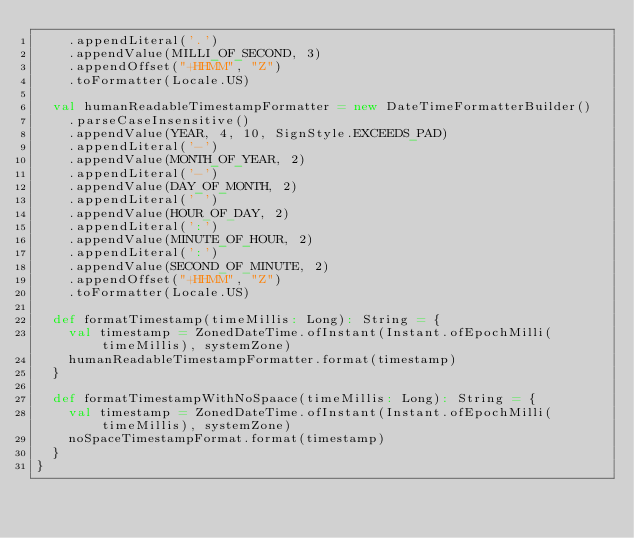Convert code to text. <code><loc_0><loc_0><loc_500><loc_500><_Scala_>    .appendLiteral('.')
    .appendValue(MILLI_OF_SECOND, 3)
    .appendOffset("+HHMM", "Z")
    .toFormatter(Locale.US)

  val humanReadableTimestampFormatter = new DateTimeFormatterBuilder()
    .parseCaseInsensitive()
    .appendValue(YEAR, 4, 10, SignStyle.EXCEEDS_PAD)
    .appendLiteral('-')
    .appendValue(MONTH_OF_YEAR, 2)
    .appendLiteral('-')
    .appendValue(DAY_OF_MONTH, 2)
    .appendLiteral(' ')
    .appendValue(HOUR_OF_DAY, 2)
    .appendLiteral(':')
    .appendValue(MINUTE_OF_HOUR, 2)
    .appendLiteral(':')
    .appendValue(SECOND_OF_MINUTE, 2)
    .appendOffset("+HHMM", "Z")
    .toFormatter(Locale.US)

  def formatTimestamp(timeMillis: Long): String = {
    val timestamp = ZonedDateTime.ofInstant(Instant.ofEpochMilli(timeMillis), systemZone)
    humanReadableTimestampFormatter.format(timestamp)
  }

  def formatTimestampWithNoSpaace(timeMillis: Long): String = {
    val timestamp = ZonedDateTime.ofInstant(Instant.ofEpochMilli(timeMillis), systemZone)
    noSpaceTimestampFormat.format(timestamp)
  }
}
</code> 